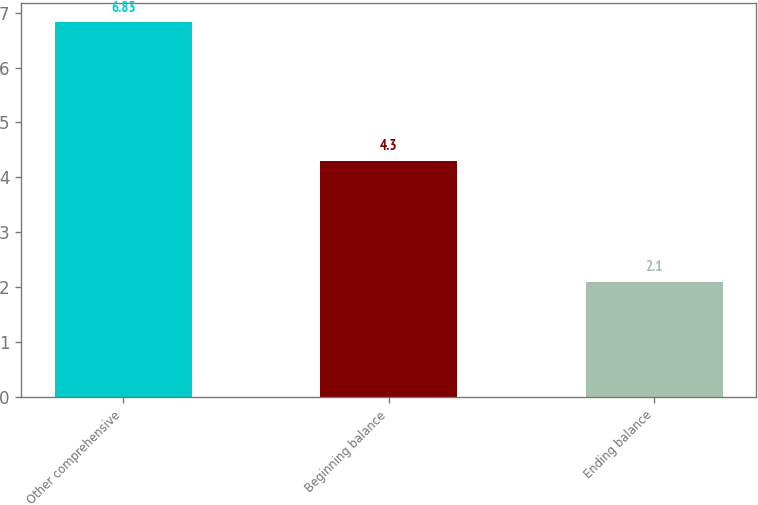<chart> <loc_0><loc_0><loc_500><loc_500><bar_chart><fcel>Other comprehensive<fcel>Beginning balance<fcel>Ending balance<nl><fcel>6.83<fcel>4.3<fcel>2.1<nl></chart> 